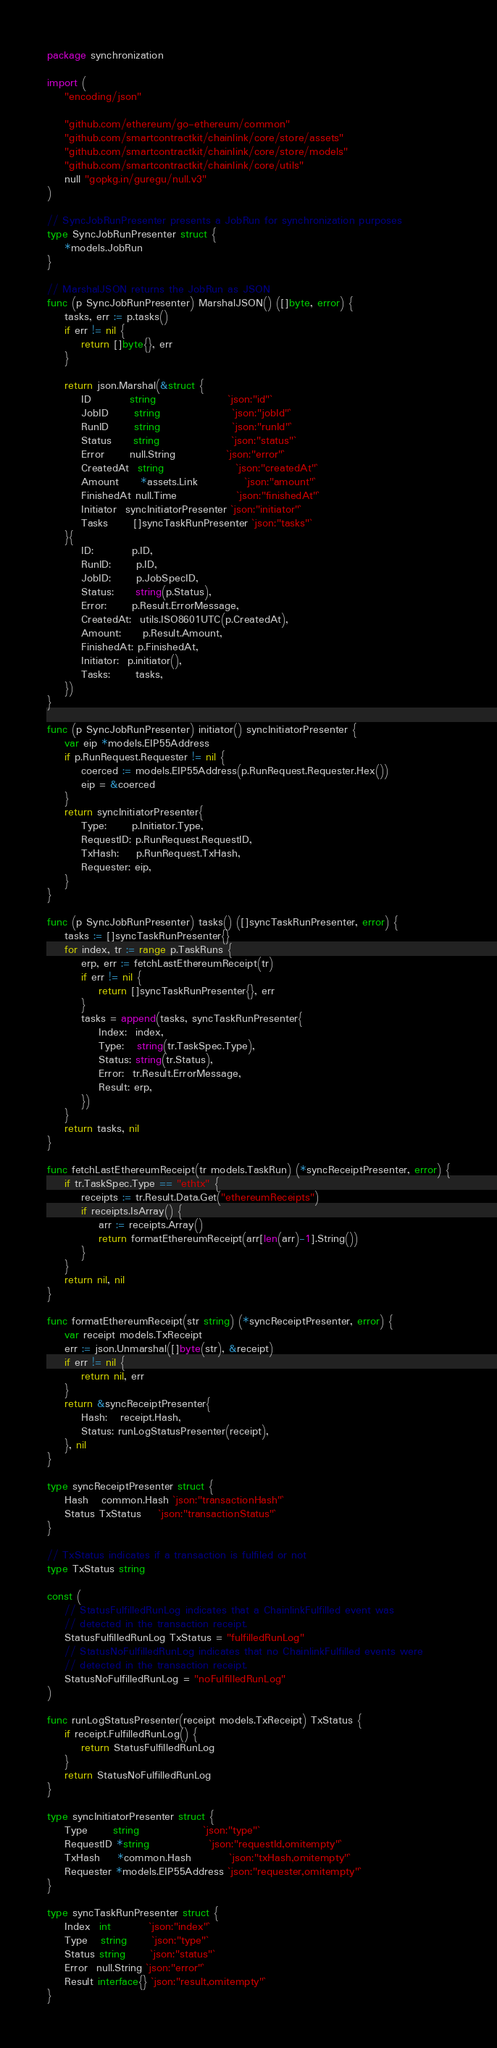Convert code to text. <code><loc_0><loc_0><loc_500><loc_500><_Go_>package synchronization

import (
	"encoding/json"

	"github.com/ethereum/go-ethereum/common"
	"github.com/smartcontractkit/chainlink/core/store/assets"
	"github.com/smartcontractkit/chainlink/core/store/models"
	"github.com/smartcontractkit/chainlink/core/utils"
	null "gopkg.in/guregu/null.v3"
)

// SyncJobRunPresenter presents a JobRun for synchronization purposes
type SyncJobRunPresenter struct {
	*models.JobRun
}

// MarshalJSON returns the JobRun as JSON
func (p SyncJobRunPresenter) MarshalJSON() ([]byte, error) {
	tasks, err := p.tasks()
	if err != nil {
		return []byte{}, err
	}

	return json.Marshal(&struct {
		ID         string                 `json:"id"`
		JobID      string                 `json:"jobId"`
		RunID      string                 `json:"runId"`
		Status     string                 `json:"status"`
		Error      null.String            `json:"error"`
		CreatedAt  string                 `json:"createdAt"`
		Amount     *assets.Link           `json:"amount"`
		FinishedAt null.Time              `json:"finishedAt"`
		Initiator  syncInitiatorPresenter `json:"initiator"`
		Tasks      []syncTaskRunPresenter `json:"tasks"`
	}{
		ID:         p.ID,
		RunID:      p.ID,
		JobID:      p.JobSpecID,
		Status:     string(p.Status),
		Error:      p.Result.ErrorMessage,
		CreatedAt:  utils.ISO8601UTC(p.CreatedAt),
		Amount:     p.Result.Amount,
		FinishedAt: p.FinishedAt,
		Initiator:  p.initiator(),
		Tasks:      tasks,
	})
}

func (p SyncJobRunPresenter) initiator() syncInitiatorPresenter {
	var eip *models.EIP55Address
	if p.RunRequest.Requester != nil {
		coerced := models.EIP55Address(p.RunRequest.Requester.Hex())
		eip = &coerced
	}
	return syncInitiatorPresenter{
		Type:      p.Initiator.Type,
		RequestID: p.RunRequest.RequestID,
		TxHash:    p.RunRequest.TxHash,
		Requester: eip,
	}
}

func (p SyncJobRunPresenter) tasks() ([]syncTaskRunPresenter, error) {
	tasks := []syncTaskRunPresenter{}
	for index, tr := range p.TaskRuns {
		erp, err := fetchLastEthereumReceipt(tr)
		if err != nil {
			return []syncTaskRunPresenter{}, err
		}
		tasks = append(tasks, syncTaskRunPresenter{
			Index:  index,
			Type:   string(tr.TaskSpec.Type),
			Status: string(tr.Status),
			Error:  tr.Result.ErrorMessage,
			Result: erp,
		})
	}
	return tasks, nil
}

func fetchLastEthereumReceipt(tr models.TaskRun) (*syncReceiptPresenter, error) {
	if tr.TaskSpec.Type == "ethtx" {
		receipts := tr.Result.Data.Get("ethereumReceipts")
		if receipts.IsArray() {
			arr := receipts.Array()
			return formatEthereumReceipt(arr[len(arr)-1].String())
		}
	}
	return nil, nil
}

func formatEthereumReceipt(str string) (*syncReceiptPresenter, error) {
	var receipt models.TxReceipt
	err := json.Unmarshal([]byte(str), &receipt)
	if err != nil {
		return nil, err
	}
	return &syncReceiptPresenter{
		Hash:   receipt.Hash,
		Status: runLogStatusPresenter(receipt),
	}, nil
}

type syncReceiptPresenter struct {
	Hash   common.Hash `json:"transactionHash"`
	Status TxStatus    `json:"transactionStatus"`
}

// TxStatus indicates if a transaction is fulfiled or not
type TxStatus string

const (
	// StatusFulfilledRunLog indicates that a ChainlinkFulfilled event was
	// detected in the transaction receipt.
	StatusFulfilledRunLog TxStatus = "fulfilledRunLog"
	// StatusNoFulfilledRunLog indicates that no ChainlinkFulfilled events were
	// detected in the transaction receipt.
	StatusNoFulfilledRunLog = "noFulfilledRunLog"
)

func runLogStatusPresenter(receipt models.TxReceipt) TxStatus {
	if receipt.FulfilledRunLog() {
		return StatusFulfilledRunLog
	}
	return StatusNoFulfilledRunLog
}

type syncInitiatorPresenter struct {
	Type      string               `json:"type"`
	RequestID *string              `json:"requestId,omitempty"`
	TxHash    *common.Hash         `json:"txHash,omitempty"`
	Requester *models.EIP55Address `json:"requester,omitempty"`
}

type syncTaskRunPresenter struct {
	Index  int         `json:"index"`
	Type   string      `json:"type"`
	Status string      `json:"status"`
	Error  null.String `json:"error"`
	Result interface{} `json:"result,omitempty"`
}
</code> 